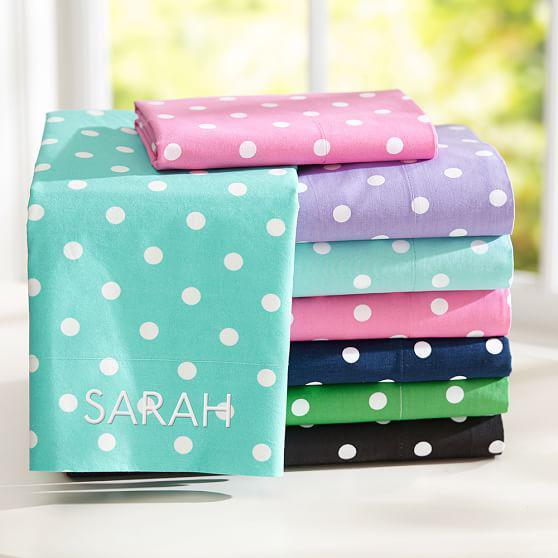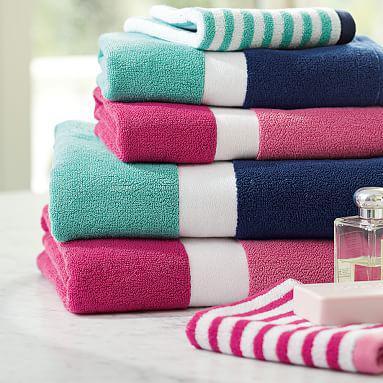The first image is the image on the left, the second image is the image on the right. For the images shown, is this caption "All images contain towels with a spotted pattern." true? Answer yes or no. No. 